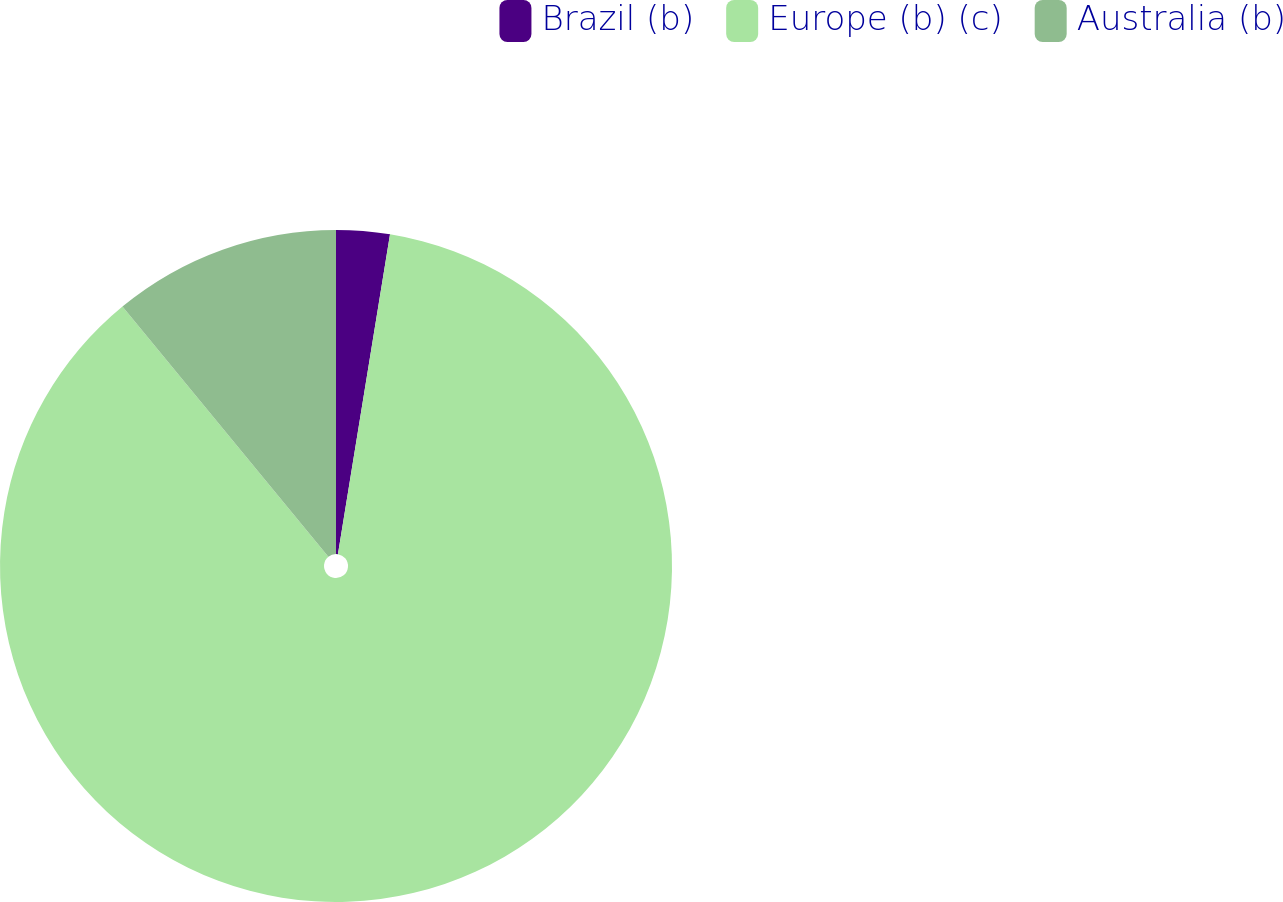<chart> <loc_0><loc_0><loc_500><loc_500><pie_chart><fcel>Brazil (b)<fcel>Europe (b) (c)<fcel>Australia (b)<nl><fcel>2.57%<fcel>86.46%<fcel>10.96%<nl></chart> 